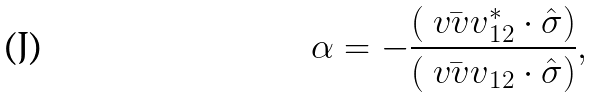Convert formula to latex. <formula><loc_0><loc_0><loc_500><loc_500>\alpha = - \frac { ( \bar { \ v v { v } } ^ { * } _ { 1 2 } \cdot \hat { \sigma } ) } { ( \bar { \ v v { v } } _ { 1 2 } \cdot \hat { \sigma } ) } ,</formula> 